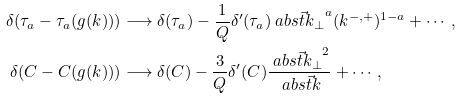<formula> <loc_0><loc_0><loc_500><loc_500>\delta ( \tau _ { a } - \tau _ { a } ( g ( k ) ) ) & \longrightarrow \delta ( \tau _ { a } ) - \frac { 1 } { Q } \delta ^ { \prime } ( \tau _ { a } ) \ a b s { \vec { t } { k } _ { \perp } } ^ { a } ( k ^ { - , + } ) ^ { 1 - a } + \cdots , \\ \delta ( C - C ( g ( k ) ) ) & \longrightarrow \delta ( C ) - \frac { 3 } { Q } \delta ^ { \prime } ( C ) \frac { \ a b s { \vec { t } { k } _ { \perp } } ^ { 2 } } { \ a b s { \vec { t } { k } } } + \cdots ,</formula> 